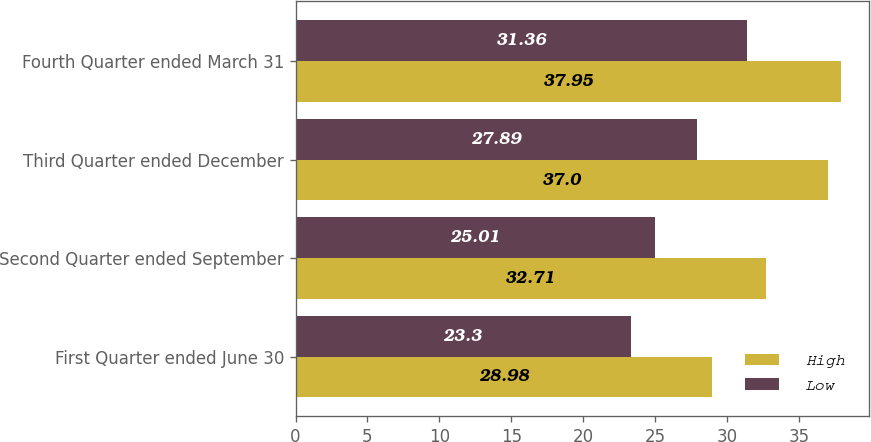Convert chart to OTSL. <chart><loc_0><loc_0><loc_500><loc_500><stacked_bar_chart><ecel><fcel>First Quarter ended June 30<fcel>Second Quarter ended September<fcel>Third Quarter ended December<fcel>Fourth Quarter ended March 31<nl><fcel>High<fcel>28.98<fcel>32.71<fcel>37<fcel>37.95<nl><fcel>Low<fcel>23.3<fcel>25.01<fcel>27.89<fcel>31.36<nl></chart> 